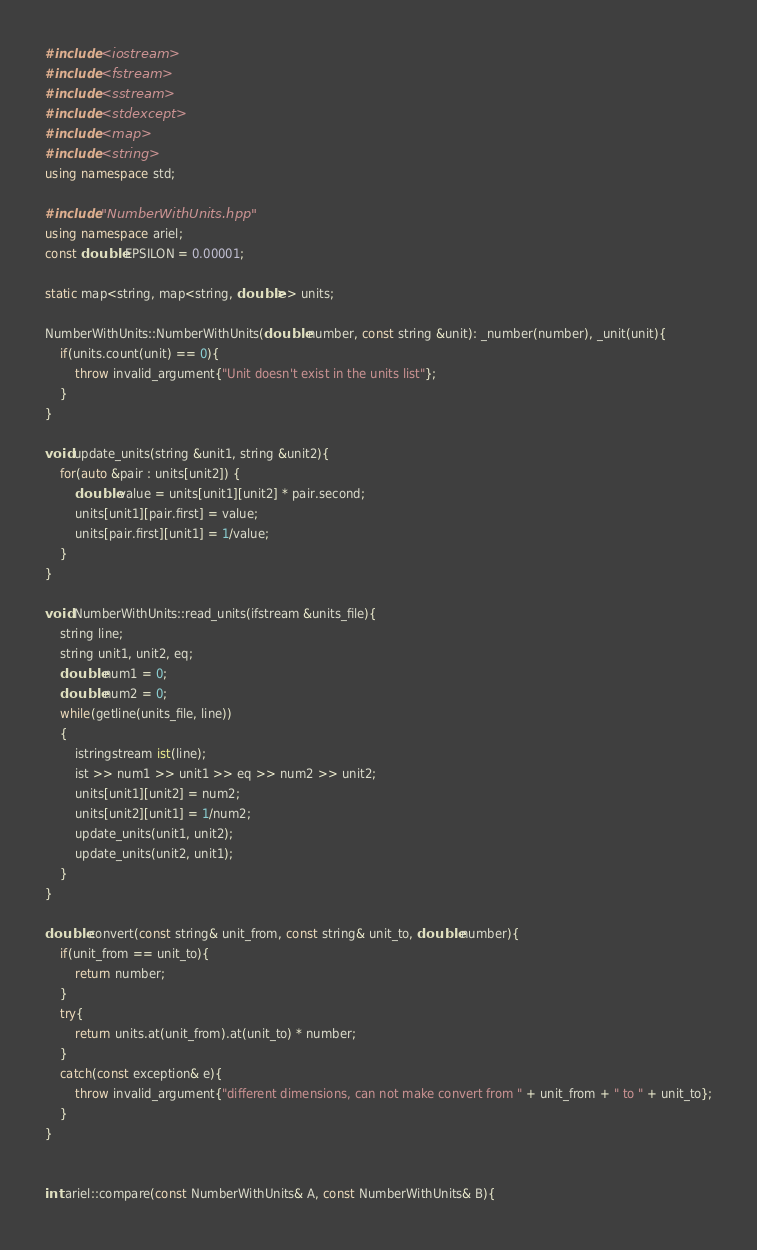Convert code to text. <code><loc_0><loc_0><loc_500><loc_500><_C++_>#include <iostream>
#include <fstream>
#include <sstream>
#include <stdexcept>
#include <map>
#include <string>
using namespace std;

#include "NumberWithUnits.hpp"
using namespace ariel;
const double EPSILON = 0.00001;

static map<string, map<string, double>> units;

NumberWithUnits::NumberWithUnits(double number, const string &unit): _number(number), _unit(unit){
    if(units.count(unit) == 0){
        throw invalid_argument{"Unit doesn't exist in the units list"};
    }
}

void update_units(string &unit1, string &unit2){
    for(auto &pair : units[unit2]) {
        double value = units[unit1][unit2] * pair.second;
        units[unit1][pair.first] = value;
        units[pair.first][unit1] = 1/value;
    }
}

void NumberWithUnits::read_units(ifstream &units_file){
    string line;
    string unit1, unit2, eq;
    double num1 = 0;
    double num2 = 0;
    while(getline(units_file, line))
    {
        istringstream ist(line);
        ist >> num1 >> unit1 >> eq >> num2 >> unit2;
        units[unit1][unit2] = num2;
        units[unit2][unit1] = 1/num2;
        update_units(unit1, unit2);
        update_units(unit2, unit1);
    }
}

double convert(const string& unit_from, const string& unit_to, double number){
    if(unit_from == unit_to){
        return number;
    }
    try{
        return units.at(unit_from).at(unit_to) * number;
    }
    catch(const exception& e){
        throw invalid_argument{"different dimensions, can not make convert from " + unit_from + " to " + unit_to};
    }
}


int ariel::compare(const NumberWithUnits& A, const NumberWithUnits& B){</code> 